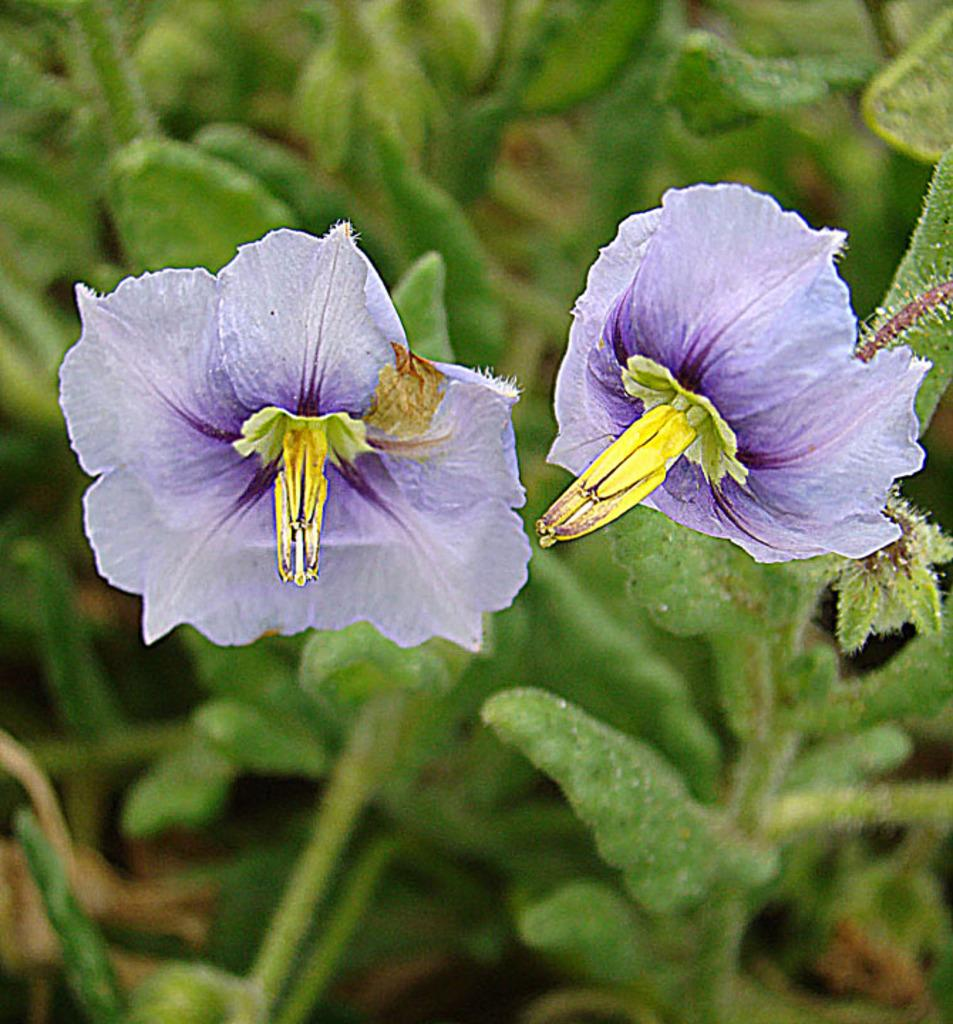What type of flower is present in the image? There is a purple and yellow color flower in the image. What color are the leaves in the image? The leaves in the image are green. How many lettuce leaves can be seen in the image? There is no lettuce present in the image. Can you describe the kicking motion of the flower in the image? The flower in the image is stationary and does not exhibit any motion, let alone a kicking motion. 